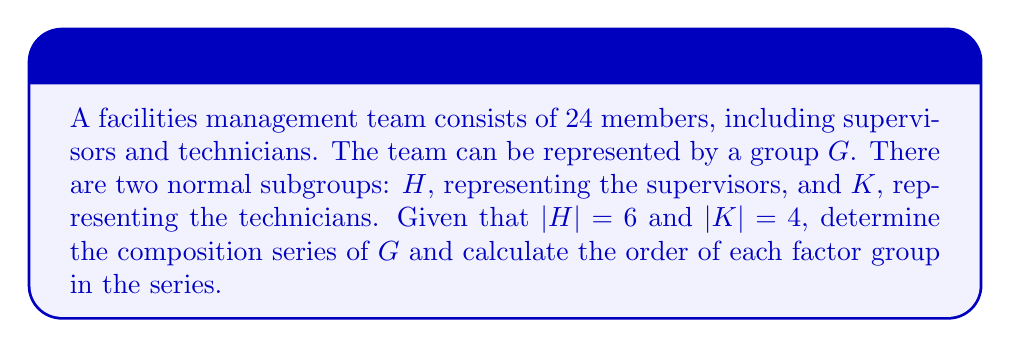Solve this math problem. To solve this problem, we'll use concepts from group theory and apply them to the maintenance team structure:

1) First, we need to understand the composition series. A composition series is a series of subgroups:

   $G = G_0 \triangleright G_1 \triangleright G_2 \triangleright ... \triangleright G_n = \{e\}$

   where each $G_i$ is a normal subgroup of $G_{i-1}$, and each factor group $G_{i-1}/G_i$ is simple.

2) We're given that $|G| = 24$, $|H| = 6$, and $|K| = 4$. 

3) By the Lattice Isomorphism Theorem, we know that $G/(H \cap K) \cong (G/H) \times (G/K)$.

4) The order of $H \cap K$ can be calculated using the formula:

   $|H \cap K| = \frac{|H| \cdot |K|}{|HK|}$

   Since $H$ and $K$ are disjoint (supervisors are not technicians), $|H \cap K| = 1$.

5) Now we can construct the composition series:

   $G \triangleright HK \triangleright H \triangleright \{e\}$

6) Let's calculate the order of each group in this series:
   
   $|G| = 24$
   $|HK| = |H| \cdot |K| = 6 \cdot 4 = 24$ (since $H$ and $K$ are disjoint)
   $|H| = 6$
   $|\{e\}| = 1$

7) The factor groups and their orders are:

   $G/(HK)$: $|G/(HK)| = |G|/|HK| = 24/24 = 1$
   $(HK)/H$: $|(HK)/H| = |HK|/|H| = 24/6 = 4$
   $H/\{e\}$: $|H/\{e\}| = |H|/|\{e\}| = 6/1 = 6$

Therefore, the composition series is $G \triangleright HK \triangleright H \triangleright \{e\}$, with factor group orders 1, 4, and 6.
Answer: The composition series is $G \triangleright HK \triangleright H \triangleright \{e\}$, with factor group orders 1, 4, and 6. 